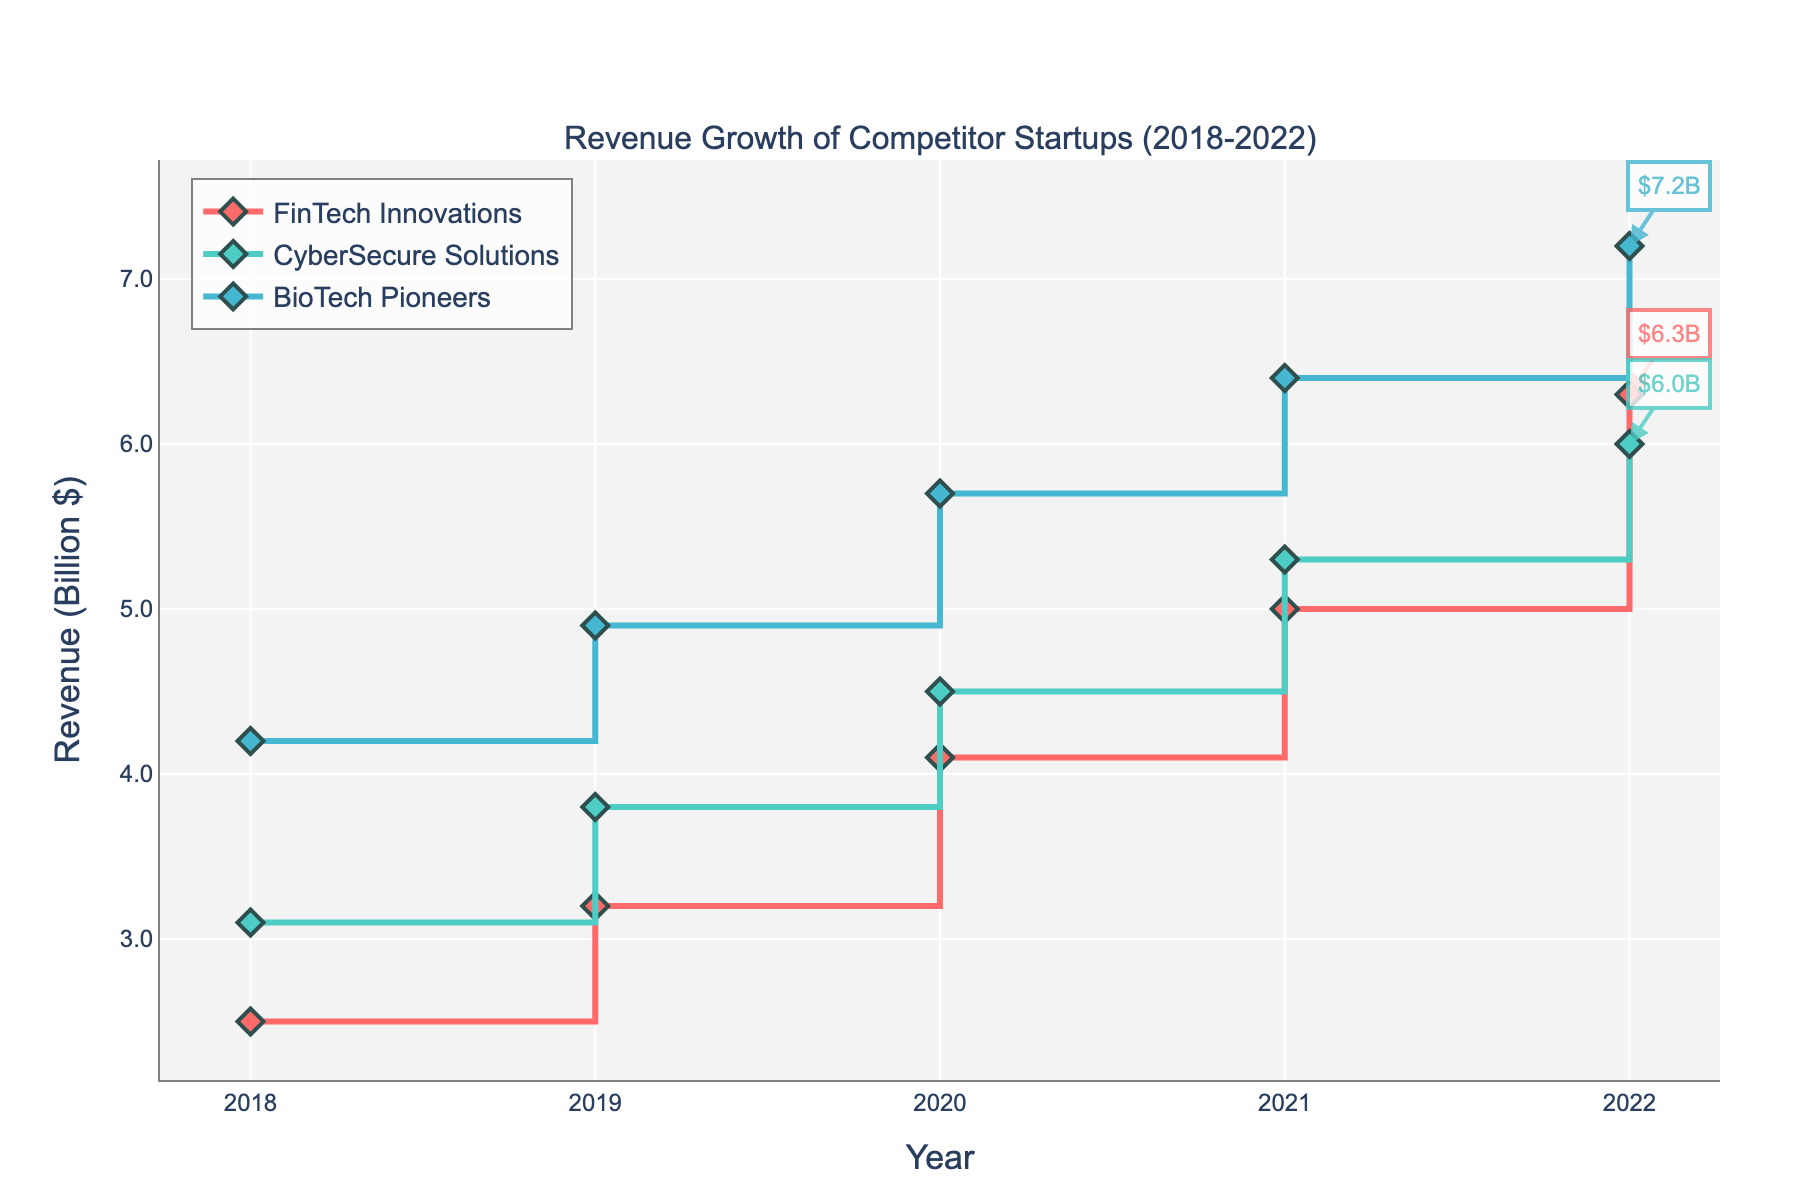What's the title of the plot? The title of the plot is located at the top of the figure. It reads "Revenue Growth of Competitor Startups (2018-2022)."
Answer: Revenue Growth of Competitor Startups (2018-2022) How many competitors are represented in the plot? By looking at the legend and the different colored lines, we can see there are three competitors represented.
Answer: 3 Which competitor had the highest revenue in 2022? In 2022, BioTech Pioneers had the highest revenue as indicated by the line and the annotation showing $7.2B.
Answer: BioTech Pioneers What year did FinTech Innovations first surpass a revenue of 4 billion dollars? By following the stair-step plot for FinTech Innovations, the line surpasses the 4 billion mark in 2020.
Answer: 2020 What's the overall trend of CyberSecure Solutions' revenue from 2018 to 2022? Examining the line of CyberSecure Solutions from 2018 to 2022, the revenue consistently increases each year, indicating a steady upward trend.
Answer: Upward trend How much did BioTech Pioneers' revenue increase from 2018 to 2022? BioTech Pioneers had a revenue of $4.2B in 2018 and $7.2B in 2022. The increase is $7.2B - $4.2B = $3B.
Answer: $3B Which competitor had the smallest revenue in 2019? By looking at the data points for 2019, FinTech Innovations had the smallest revenue at $3.2B.
Answer: FinTech Innovations Between which years did FinTech Innovations have the highest year-over-year revenue growth? FinTech Innovations had revenues of $4.1B in 2020 and $5.0B in 2021, showing the highest year-over-year growth of $5.0B - $4.1B = $0.9B.
Answer: 2020 to 2021 How does the revenue growth pattern of BioTech Pioneers compare to FinTech Innovations? By comparing the lines for BioTech Pioneers and FinTech Innovations, both show consistent growth, but BioTech Pioneers starts at a higher revenue and consistently remains higher throughout the years.
Answer: BioTech Pioneers consistently higher In which year did CyberSecure Solutions' revenue growth slow down the most? Observing CyberSecure Solutions' line, the growth rate appears to slow down the most from 2021 ($5.3B) to 2022 ($6.0B), which is the smallest increase ($6.0B - $5.3B = $0.7B).
Answer: 2021 to 2022 